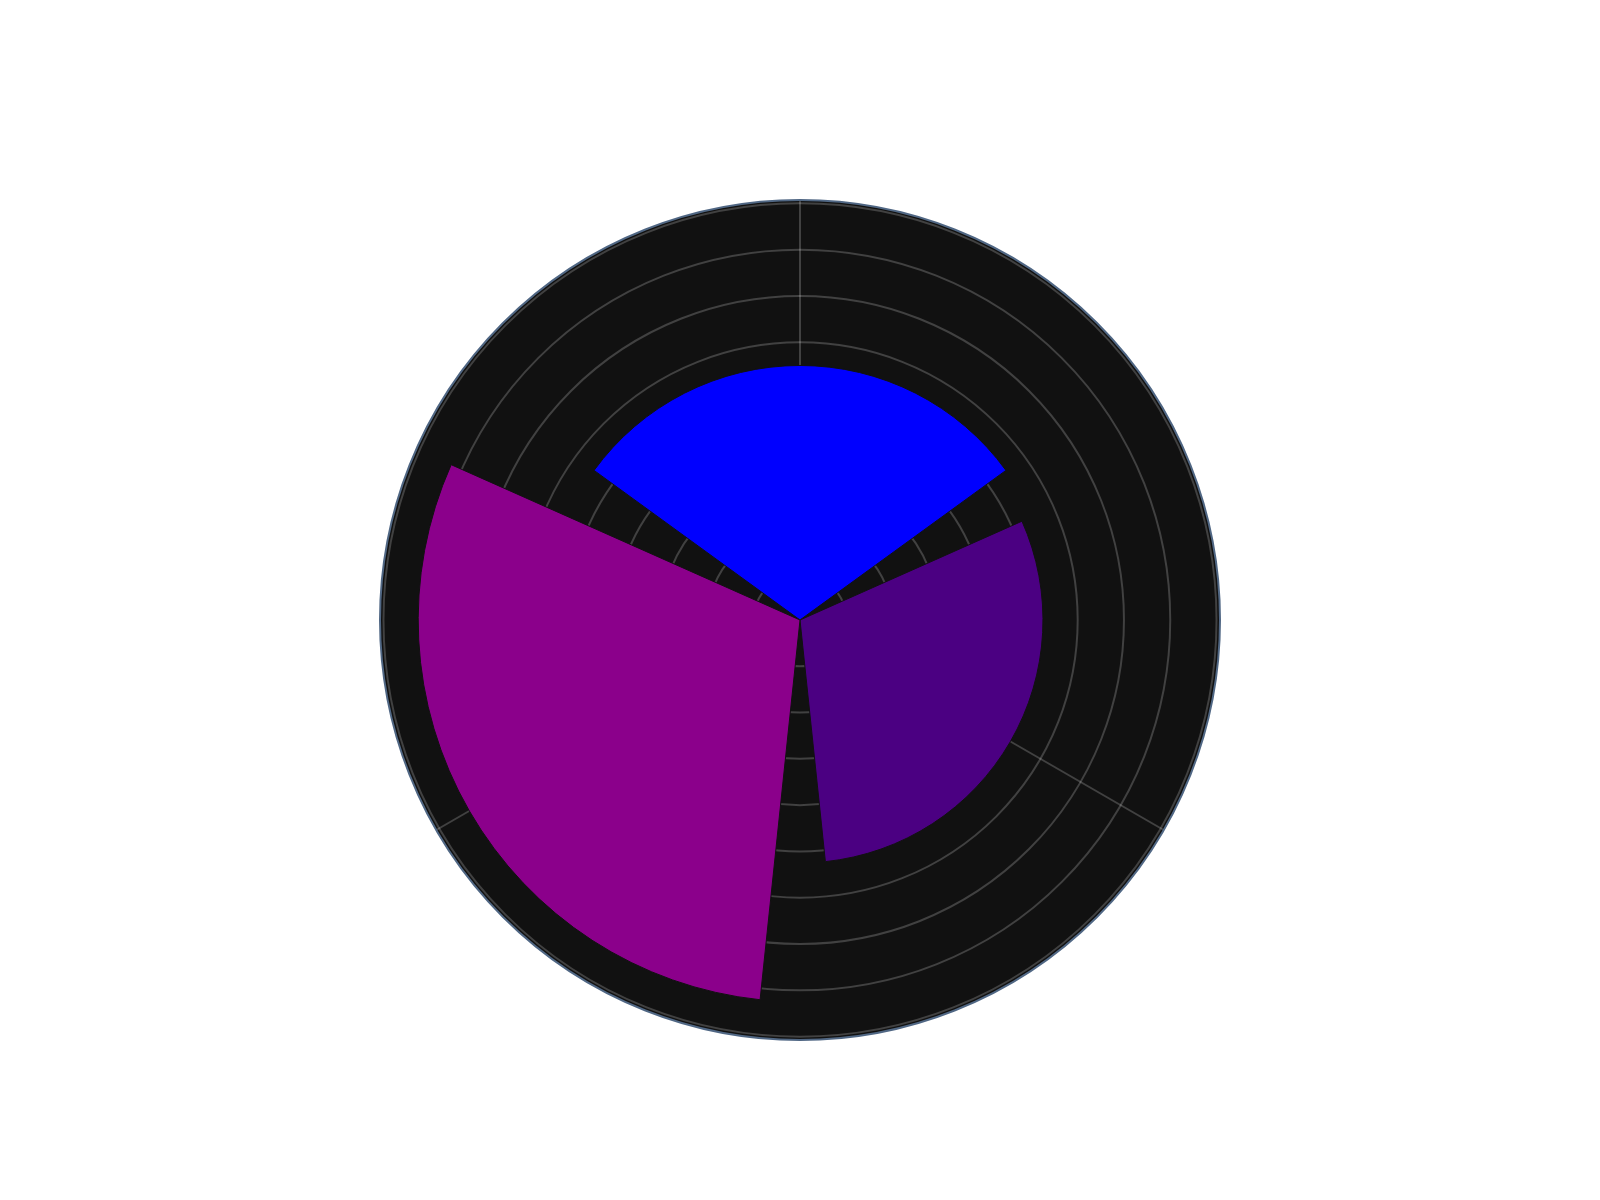What's the title of the figure? The title of the figure is prominently displayed at the top and describes the content of the chart.
Answer: Distribution of Coding Languages in Finnish Tech Industry Projects Which language is used in the most projects overall? The length of the corresponding bar in the rose chart indicates the total number of projects for each language. The longest bar represents this language.
Answer: Python What is the total number of projects across all companies for Java? Sum the values of the "Projects" for Java from each company (Nokia, Supercell, Rovio, Wartsila), as indicated by the chart. Java has 30 (Nokia) + 35 (Supercell) + 20 (Rovio) + 20 (Wartsila).
Answer: 105 Which company has the most projects utilizing C++? Observe the radial representation of the projects for each company and identify the company with the maximum in the C++ category. Wartsila has the longest bar for C++ projects.
Answer: Wartsila How does the use of Python compare to C++ across all companies? Compare the aggregate totals of the projects for Python and C++ shown in the rose chart. Sum the values for each language from all companies: Python (50+40+45+30) and C++ (20+25+15+50).
Answer: Python has more projects than C++ What is the difference in the number of projects between Python and Java in Supercell? Find the bars for Python and Java specific to Supercell, then calculate the difference: Python has 40 projects and Java has 35.
Answer: 5 What is the average number of projects per language? Sum the total projects for all languages and divide by the number of languages. Python (165) + C++ (110) + Java (105). The total is 380, divided by 3 languages.
Answer: 126.67 Which language shows the least variance in the number of projects across different companies? Look at the length of the bars for each language across all companies to assess the consistency. Java has relatively balanced values (30, 35, 20, 20) compared to Python and C++.
Answer: Java How many more projects does Nokia have using Python compared to C++? Compare the bars for Nokia under Python and C++ categories. Nokia has 50 projects for Python and 20 for C++. Calculate the difference.
Answer: 30 Which language is used the least in Rovio? Identify the shortest bar for Rovio among the three languages, which is C++.
Answer: C++ 